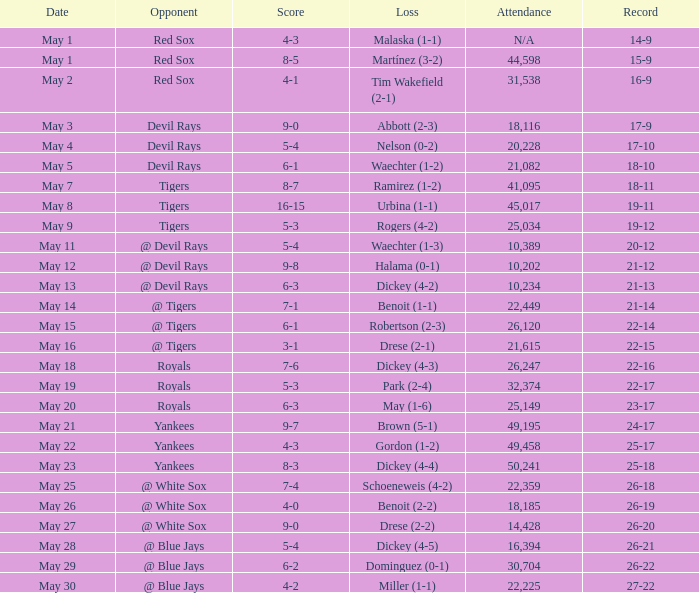What was the score of the game that had a loss of Drese (2-2)? 9-0. 